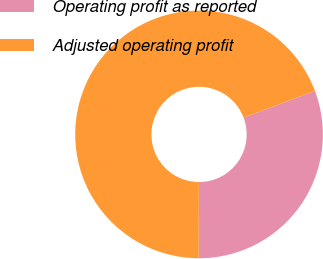<chart> <loc_0><loc_0><loc_500><loc_500><pie_chart><fcel>Operating profit as reported<fcel>Adjusted operating profit<nl><fcel>30.77%<fcel>69.23%<nl></chart> 